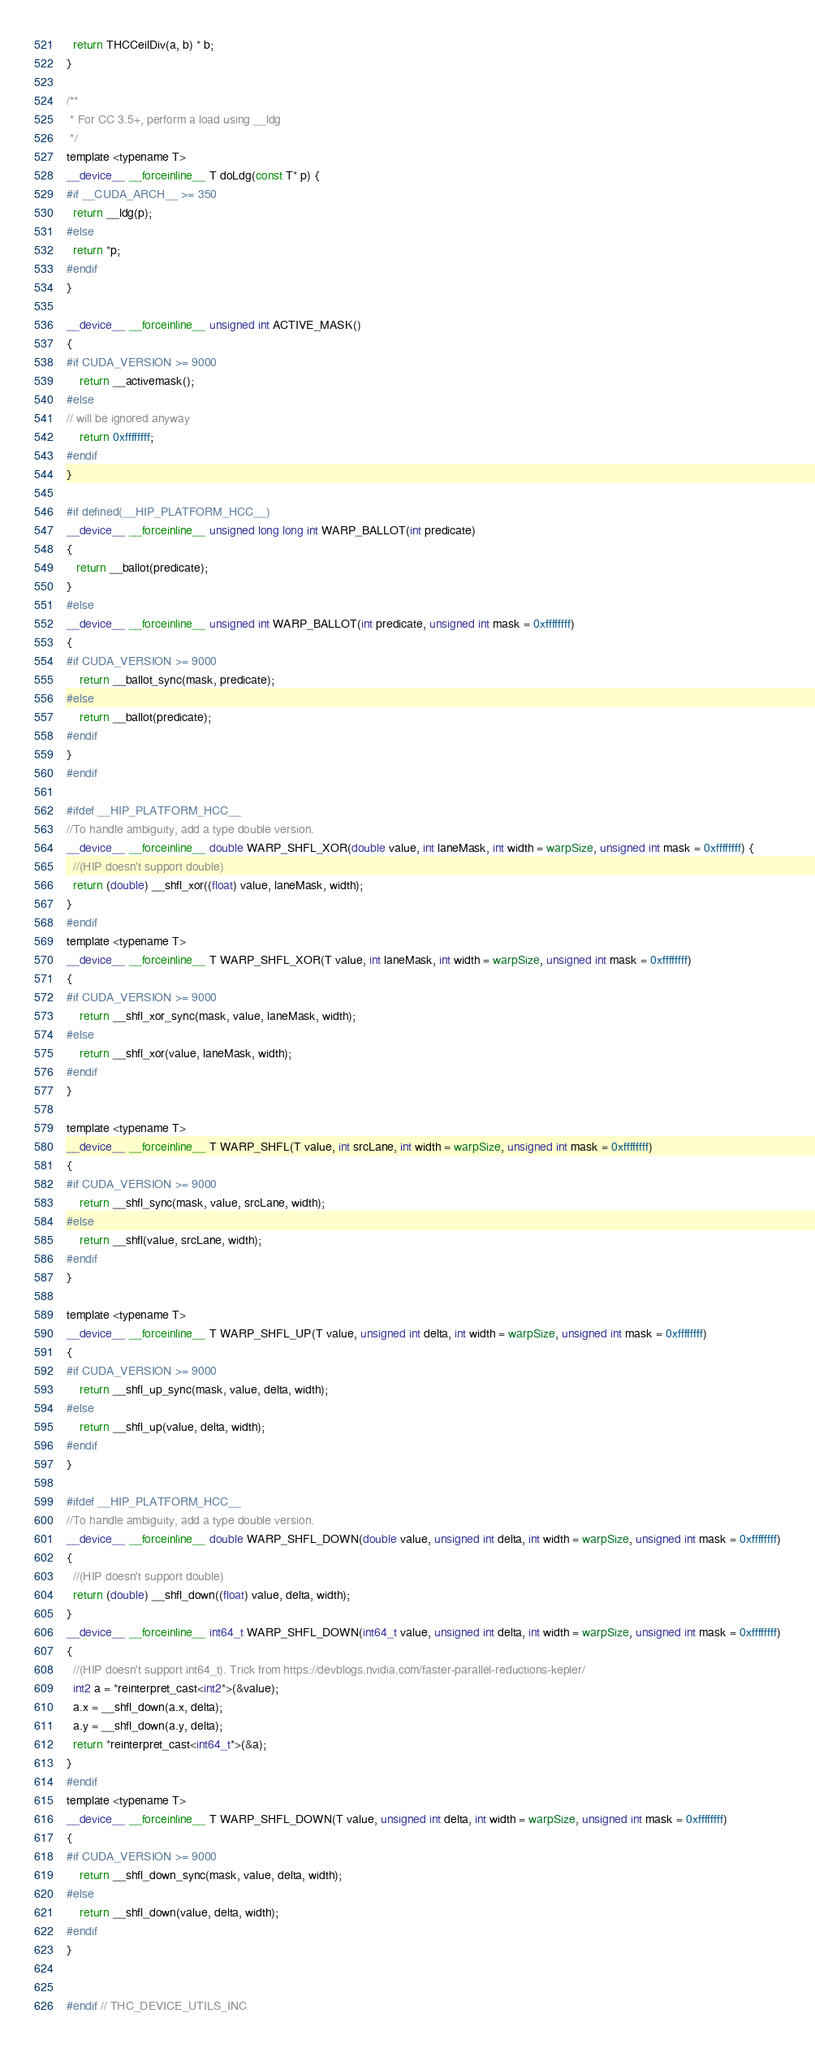<code> <loc_0><loc_0><loc_500><loc_500><_Cuda_>  return THCCeilDiv(a, b) * b;
}

/**
 * For CC 3.5+, perform a load using __ldg
 */
template <typename T>
__device__ __forceinline__ T doLdg(const T* p) {
#if __CUDA_ARCH__ >= 350
  return __ldg(p);
#else
  return *p;
#endif
}

__device__ __forceinline__ unsigned int ACTIVE_MASK()
{
#if CUDA_VERSION >= 9000
    return __activemask();
#else
// will be ignored anyway
    return 0xffffffff;
#endif
}

#if defined(__HIP_PLATFORM_HCC__)
__device__ __forceinline__ unsigned long long int WARP_BALLOT(int predicate)
{
   return __ballot(predicate);
}
#else
__device__ __forceinline__ unsigned int WARP_BALLOT(int predicate, unsigned int mask = 0xffffffff)
{
#if CUDA_VERSION >= 9000
    return __ballot_sync(mask, predicate);
#else
    return __ballot(predicate);
#endif
}
#endif

#ifdef __HIP_PLATFORM_HCC__
//To handle ambiguity, add a type double version.
__device__ __forceinline__ double WARP_SHFL_XOR(double value, int laneMask, int width = warpSize, unsigned int mask = 0xffffffff) {
  //(HIP doesn't support double)
  return (double) __shfl_xor((float) value, laneMask, width);
}
#endif
template <typename T>
__device__ __forceinline__ T WARP_SHFL_XOR(T value, int laneMask, int width = warpSize, unsigned int mask = 0xffffffff)
{
#if CUDA_VERSION >= 9000
    return __shfl_xor_sync(mask, value, laneMask, width);
#else
    return __shfl_xor(value, laneMask, width);
#endif
}

template <typename T>
__device__ __forceinline__ T WARP_SHFL(T value, int srcLane, int width = warpSize, unsigned int mask = 0xffffffff)
{
#if CUDA_VERSION >= 9000
    return __shfl_sync(mask, value, srcLane, width);
#else
    return __shfl(value, srcLane, width);
#endif
}

template <typename T>
__device__ __forceinline__ T WARP_SHFL_UP(T value, unsigned int delta, int width = warpSize, unsigned int mask = 0xffffffff)
{
#if CUDA_VERSION >= 9000
    return __shfl_up_sync(mask, value, delta, width);
#else
    return __shfl_up(value, delta, width);
#endif
}

#ifdef __HIP_PLATFORM_HCC__
//To handle ambiguity, add a type double version.
__device__ __forceinline__ double WARP_SHFL_DOWN(double value, unsigned int delta, int width = warpSize, unsigned int mask = 0xffffffff)
{
  //(HIP doesn't support double)
  return (double) __shfl_down((float) value, delta, width);
}
__device__ __forceinline__ int64_t WARP_SHFL_DOWN(int64_t value, unsigned int delta, int width = warpSize, unsigned int mask = 0xffffffff)
{
  //(HIP doesn't support int64_t). Trick from https://devblogs.nvidia.com/faster-parallel-reductions-kepler/
  int2 a = *reinterpret_cast<int2*>(&value);
  a.x = __shfl_down(a.x, delta);
  a.y = __shfl_down(a.y, delta);
  return *reinterpret_cast<int64_t*>(&a);
}
#endif
template <typename T>
__device__ __forceinline__ T WARP_SHFL_DOWN(T value, unsigned int delta, int width = warpSize, unsigned int mask = 0xffffffff)
{
#if CUDA_VERSION >= 9000
    return __shfl_down_sync(mask, value, delta, width);
#else
    return __shfl_down(value, delta, width);
#endif
}


#endif // THC_DEVICE_UTILS_INC
</code> 